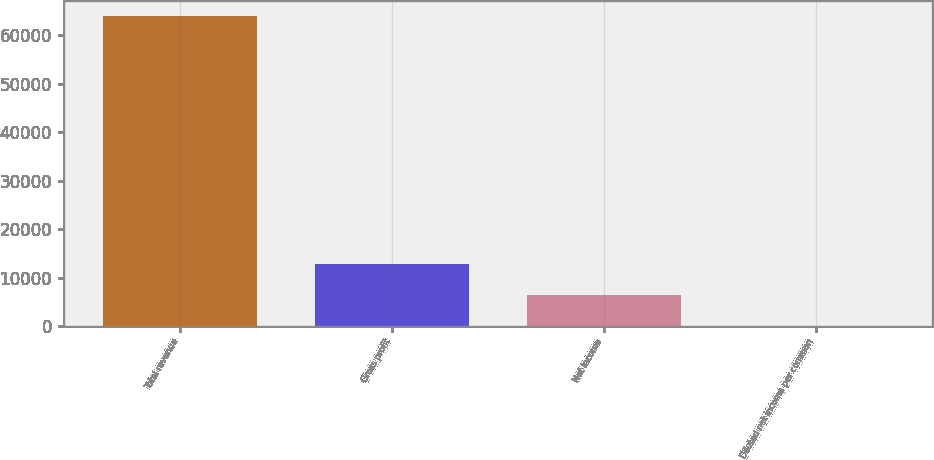<chart> <loc_0><loc_0><loc_500><loc_500><bar_chart><fcel>Total revenue<fcel>Gross profit<fcel>Net income<fcel>Diluted net income per common<nl><fcel>63950<fcel>12790.2<fcel>6395.22<fcel>0.24<nl></chart> 